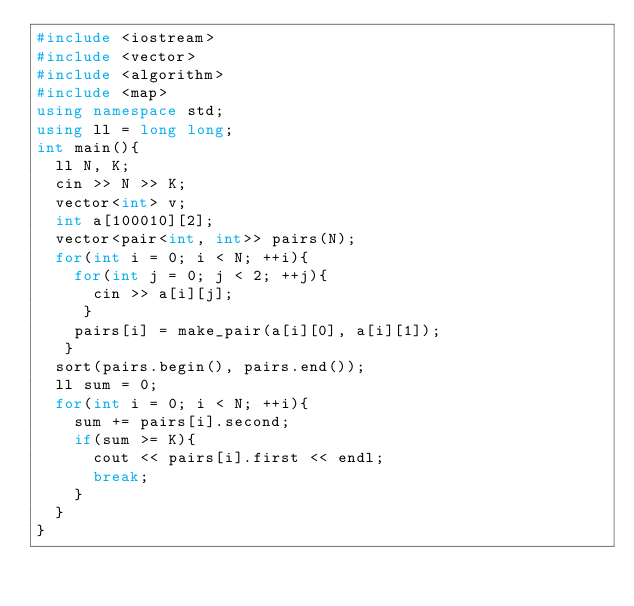<code> <loc_0><loc_0><loc_500><loc_500><_C++_>#include <iostream>
#include <vector>
#include <algorithm>
#include <map>
using namespace std;
using ll = long long;
int main(){
  ll N, K;
  cin >> N >> K;
  vector<int> v;
  int a[100010][2];
  vector<pair<int, int>> pairs(N);
  for(int i = 0; i < N; ++i){
    for(int j = 0; j < 2; ++j){
      cin >> a[i][j];
     }
    pairs[i] = make_pair(a[i][0], a[i][1]);
   }
  sort(pairs.begin(), pairs.end());
  ll sum = 0;
  for(int i = 0; i < N; ++i){
    sum += pairs[i].second;
    if(sum >= K){
      cout << pairs[i].first << endl;
      break;
    }
  }
}</code> 